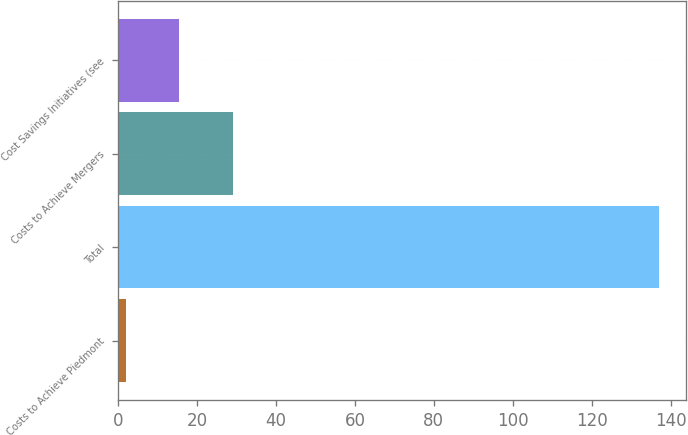Convert chart. <chart><loc_0><loc_0><loc_500><loc_500><bar_chart><fcel>Costs to Achieve Piedmont<fcel>Total<fcel>Costs to Achieve Mergers<fcel>Cost Savings Initiatives (see<nl><fcel>2<fcel>137<fcel>29<fcel>15.5<nl></chart> 